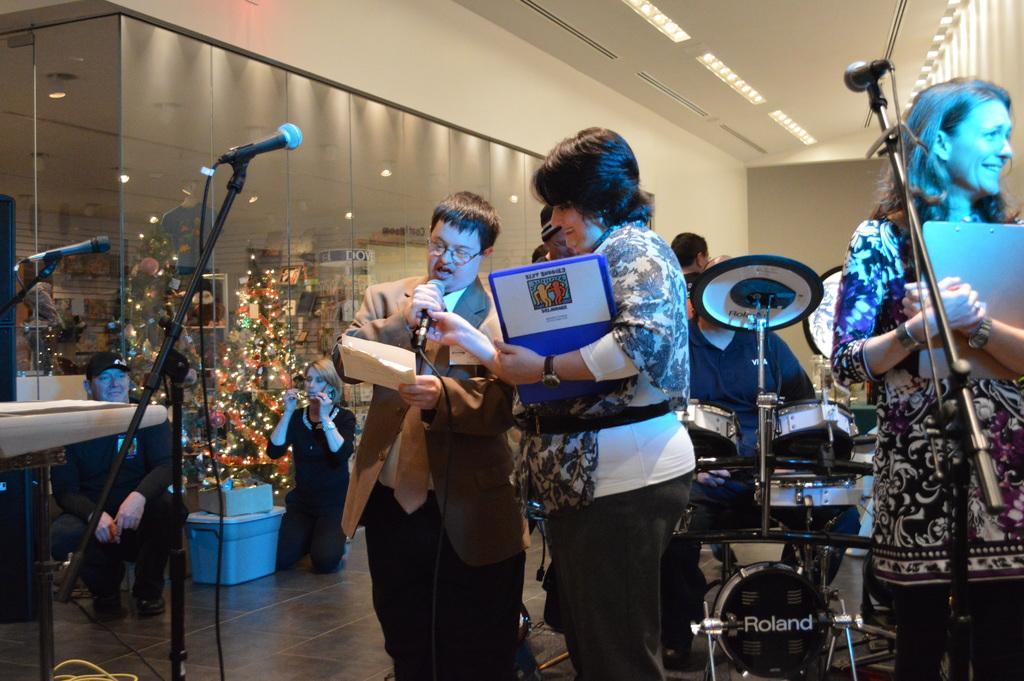Could you give a brief overview of what you see in this image? In this image there is a man and a woman holding mike and papers, in the background there is a person sitting on a chair and there are musical instruments few people are sitting on knees and few are standing and there are mike's, behind them there are walls, at the top there is a ceiling and lights. 